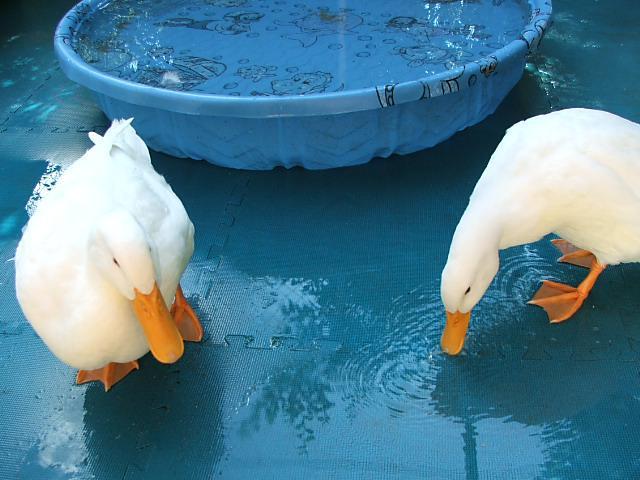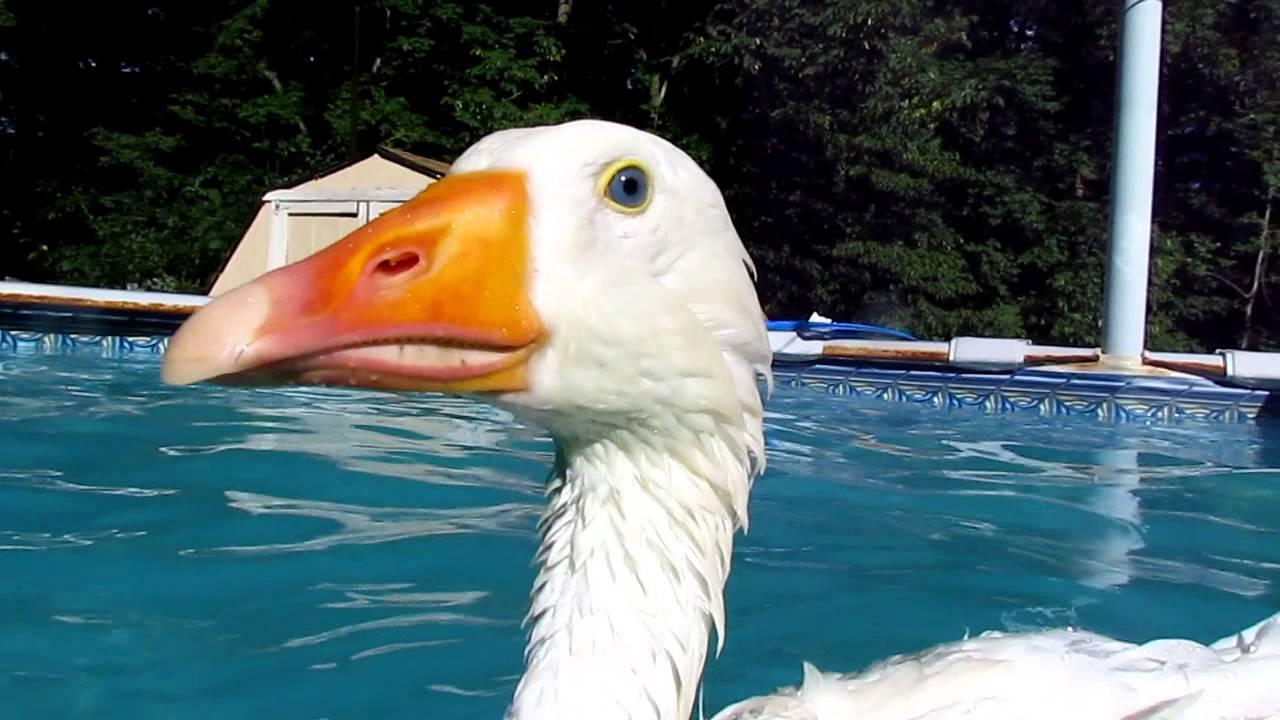The first image is the image on the left, the second image is the image on the right. Evaluate the accuracy of this statement regarding the images: "Some of the birds are darker than the others.". Is it true? Answer yes or no. No. The first image is the image on the left, the second image is the image on the right. Given the left and right images, does the statement "There are more than three ducks in water." hold true? Answer yes or no. No. 